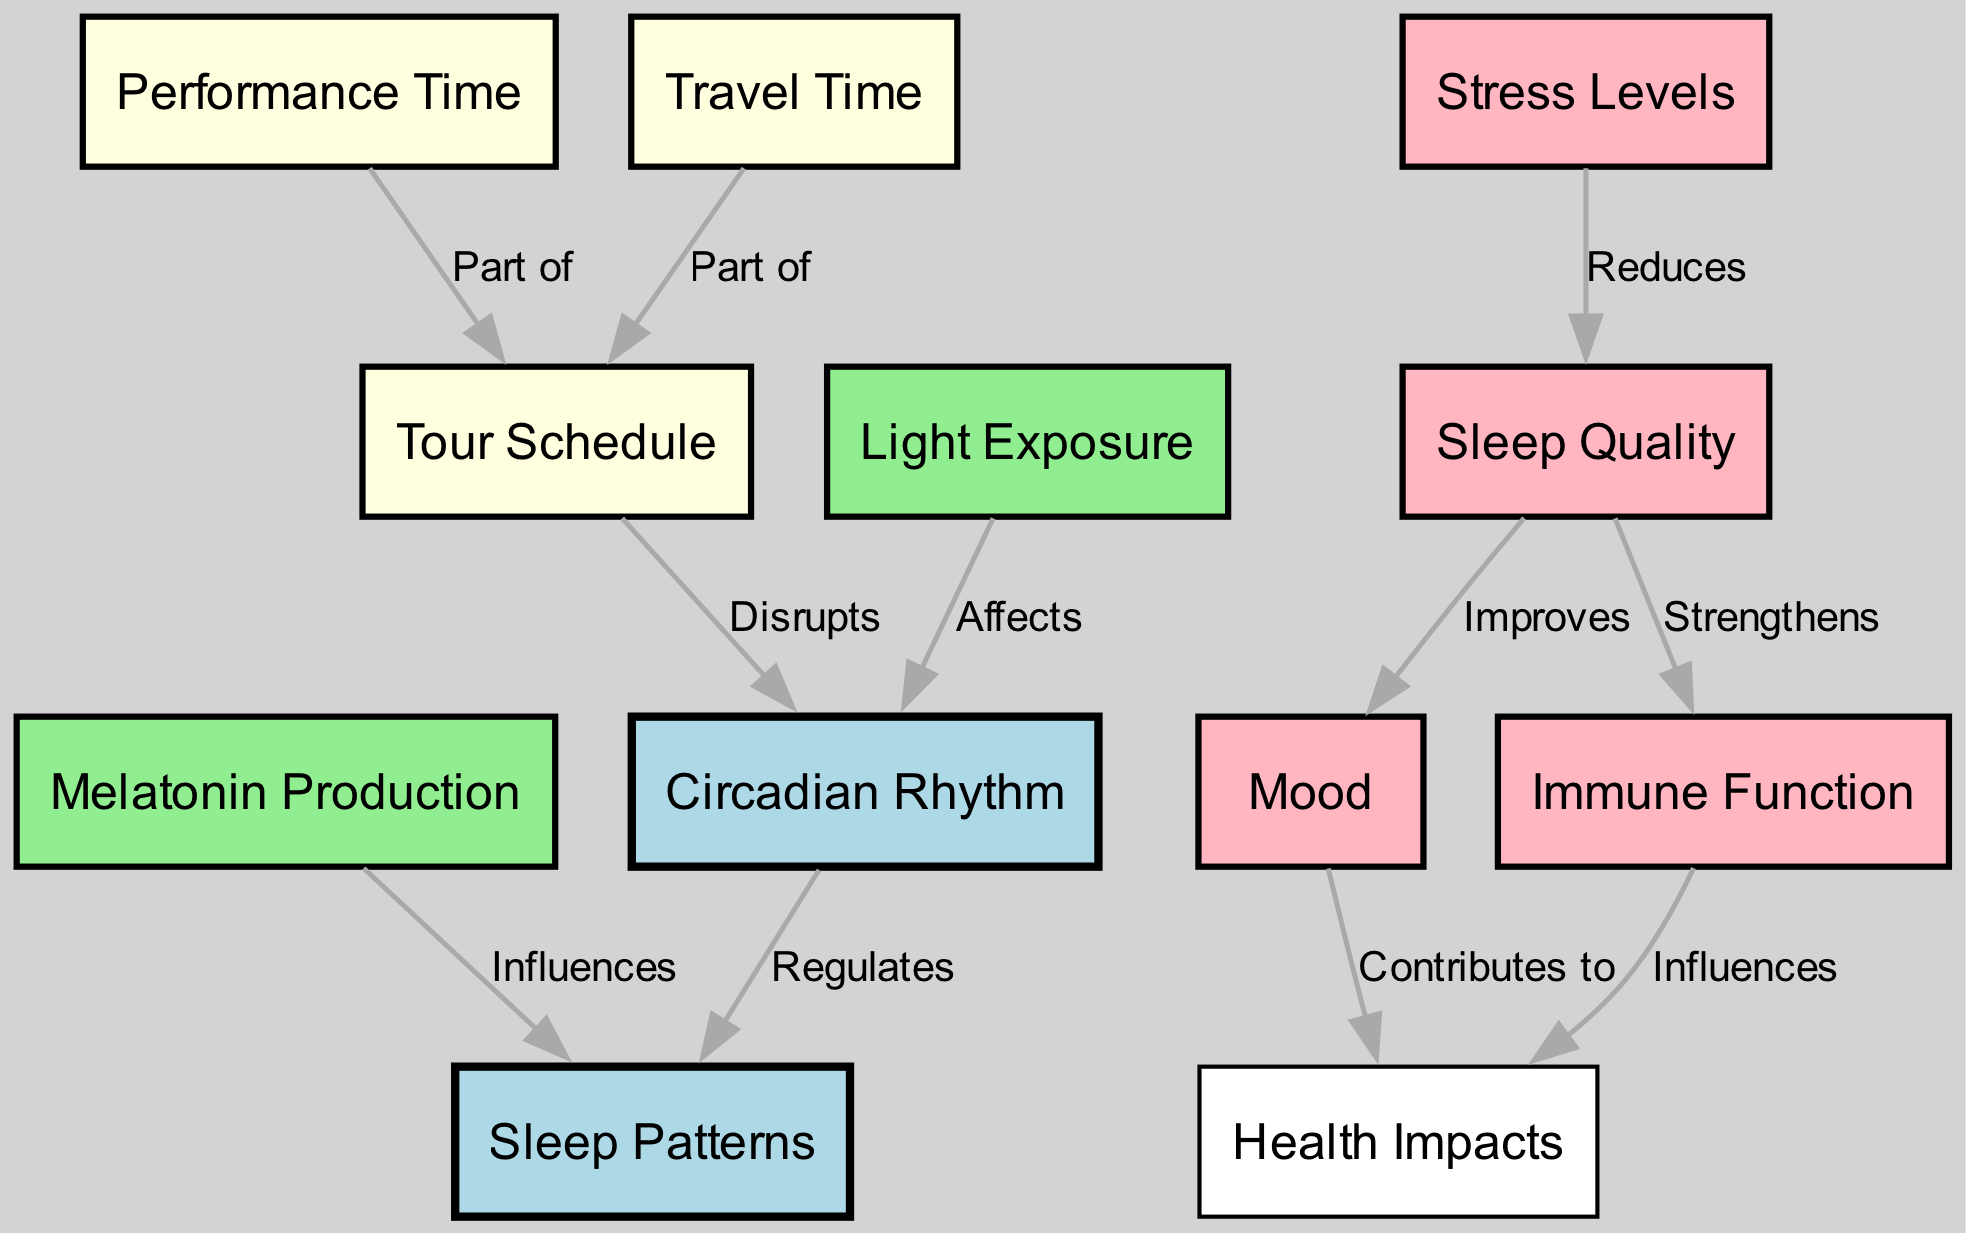What is the primary function of the Circadian Rhythm? The Circadian Rhythm regulates Sleep Patterns, which is indicated by the directed edge labeled "Regulates" from Circadian Rhythm to Sleep Patterns.
Answer: Regulates How many nodes are present in the diagram? By counting the unique nodes listed in the data, there are a total of 12 nodes.
Answer: 12 Which node is influenced by Melatonin Production? Sleep Patterns is influenced by Melatonin Production, as shown by the directed edge labeled "Influences" from Melatonin Production to Sleep Patterns.
Answer: Sleep Patterns What relationship exists between Tour Schedule and Circadian Rhythm? The Tour Schedule disrupts the Circadian Rhythm, as explained by the edge labeled "Disrupts" from Tour Schedule to Circadian Rhythm.
Answer: Disrupts How does Stress Levels affect Sleep Quality? Stress Levels reduce Sleep Quality, indicated by the edge labeled "Reduces" from Stress Levels to Sleep Quality.
Answer: Reduces What aspect of health does Mood contribute to? Mood contributes to Health Impacts, as represented by the directed edge labeled "Contributes to" from Mood to Health Impacts.
Answer: Health Impacts What is the connection between Immune Function and Health Impacts? Immune Function influences Health Impacts, as indicated by the edge labeled "Influences" from Immune Function to Health Impacts.
Answer: Influences What do Light Exposure and Circadian Rhythm share? Light Exposure affects Circadian Rhythm, as shown by the edge labeled "Affects" from Light Exposure to Circadian Rhythm.
Answer: Affects Which node has a direct impact on Sleep Quality? Stress Levels have a direct impact on Sleep Quality by reducing it, evidenced by the edge labeled "Reduces" from Stress Levels to Sleep Quality.
Answer: Sleep Quality 